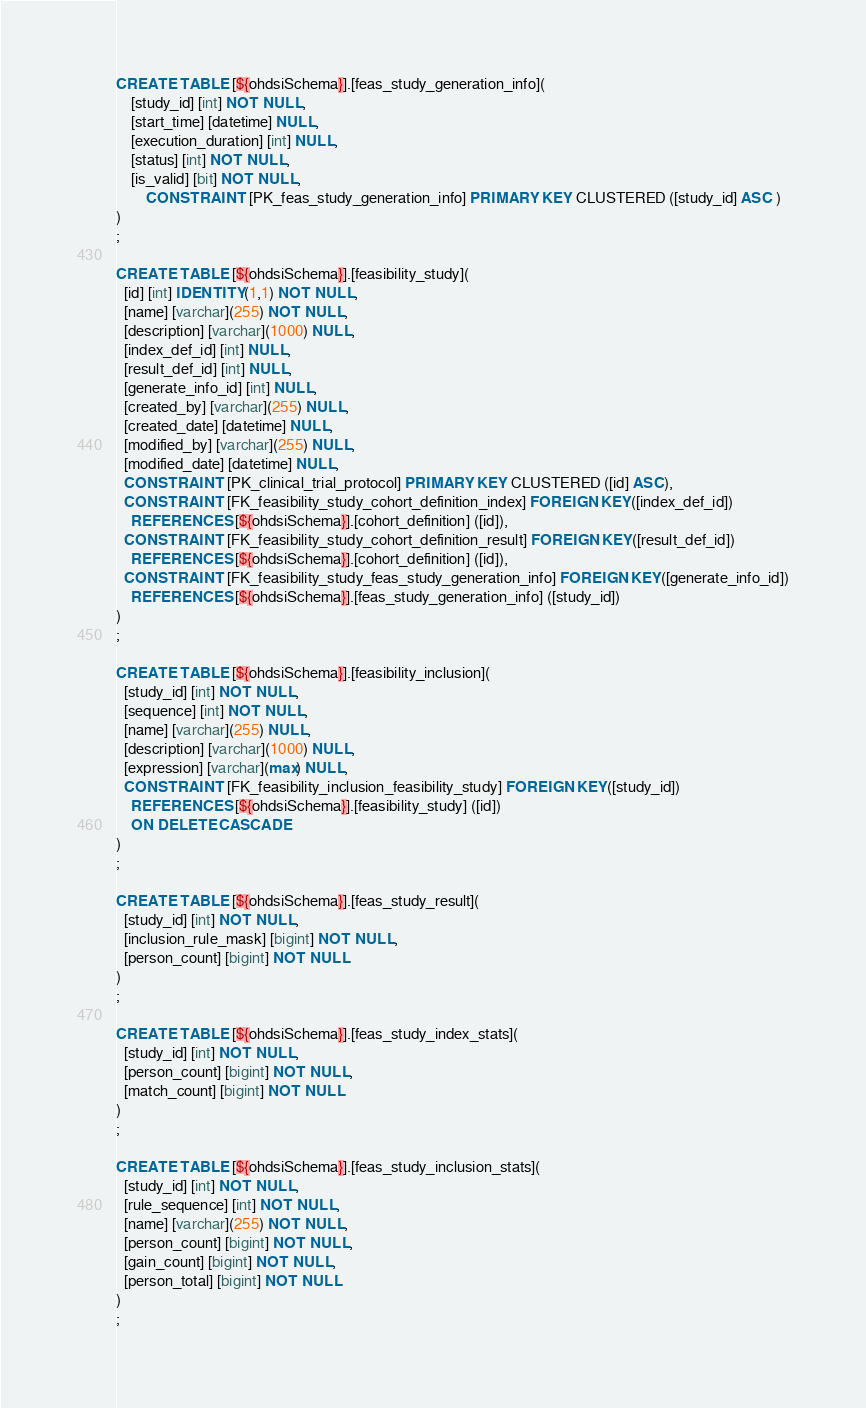Convert code to text. <code><loc_0><loc_0><loc_500><loc_500><_SQL_>CREATE TABLE [${ohdsiSchema}].[feas_study_generation_info](
	[study_id] [int] NOT NULL,
	[start_time] [datetime] NULL,
	[execution_duration] [int] NULL,
	[status] [int] NOT NULL,
	[is_valid] [bit] NOT NULL,
        CONSTRAINT [PK_feas_study_generation_info] PRIMARY KEY CLUSTERED ([study_id] ASC )
)
;

CREATE TABLE [${ohdsiSchema}].[feasibility_study](
  [id] [int] IDENTITY(1,1) NOT NULL,
  [name] [varchar](255) NOT NULL,
  [description] [varchar](1000) NULL,
  [index_def_id] [int] NULL,
  [result_def_id] [int] NULL,
  [generate_info_id] [int] NULL,
  [created_by] [varchar](255) NULL,
  [created_date] [datetime] NULL,
  [modified_by] [varchar](255) NULL,
  [modified_date] [datetime] NULL,
  CONSTRAINT [PK_clinical_trial_protocol] PRIMARY KEY CLUSTERED ([id] ASC),
  CONSTRAINT [FK_feasibility_study_cohort_definition_index] FOREIGN KEY([index_def_id])
    REFERENCES [${ohdsiSchema}].[cohort_definition] ([id]),
  CONSTRAINT [FK_feasibility_study_cohort_definition_result] FOREIGN KEY([result_def_id])
    REFERENCES [${ohdsiSchema}].[cohort_definition] ([id]),
  CONSTRAINT [FK_feasibility_study_feas_study_generation_info] FOREIGN KEY([generate_info_id])
    REFERENCES [${ohdsiSchema}].[feas_study_generation_info] ([study_id])
)
;

CREATE TABLE [${ohdsiSchema}].[feasibility_inclusion](
  [study_id] [int] NOT NULL,
  [sequence] [int] NOT NULL,
  [name] [varchar](255) NULL,
  [description] [varchar](1000) NULL,
  [expression] [varchar](max) NULL,
  CONSTRAINT [FK_feasibility_inclusion_feasibility_study] FOREIGN KEY([study_id])
    REFERENCES [${ohdsiSchema}].[feasibility_study] ([id])
    ON DELETE CASCADE
)
;

CREATE TABLE [${ohdsiSchema}].[feas_study_result](
  [study_id] [int] NOT NULL,
  [inclusion_rule_mask] [bigint] NOT NULL,
  [person_count] [bigint] NOT NULL
)
;

CREATE TABLE [${ohdsiSchema}].[feas_study_index_stats](
  [study_id] [int] NOT NULL,
  [person_count] [bigint] NOT NULL,
  [match_count] [bigint] NOT NULL
)
;

CREATE TABLE [${ohdsiSchema}].[feas_study_inclusion_stats](
  [study_id] [int] NOT NULL,
  [rule_sequence] [int] NOT NULL,
  [name] [varchar](255) NOT NULL,
  [person_count] [bigint] NOT NULL,
  [gain_count] [bigint] NOT NULL,
  [person_total] [bigint] NOT NULL
)
;

</code> 